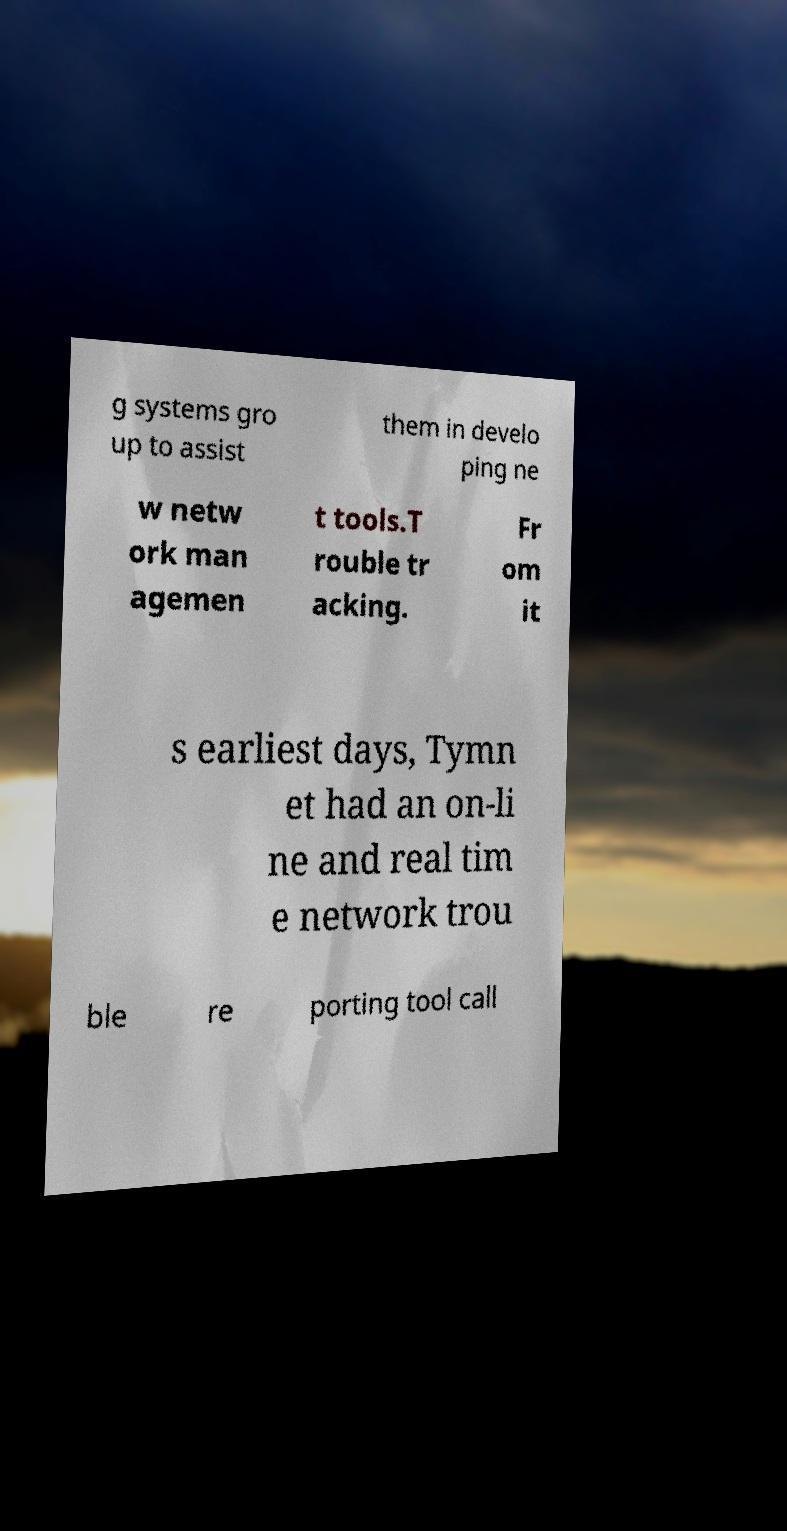What messages or text are displayed in this image? I need them in a readable, typed format. g systems gro up to assist them in develo ping ne w netw ork man agemen t tools.T rouble tr acking. Fr om it s earliest days, Tymn et had an on-li ne and real tim e network trou ble re porting tool call 